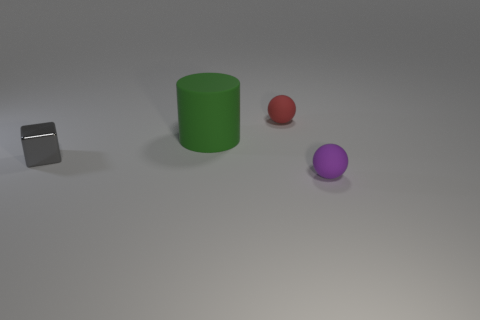What color is the large rubber object?
Make the answer very short. Green. There is a sphere that is on the right side of the red object; what number of red matte spheres are in front of it?
Give a very brief answer. 0. Is the size of the green rubber cylinder the same as the sphere that is in front of the large cylinder?
Provide a succinct answer. No. Do the gray cube and the purple matte sphere have the same size?
Provide a short and direct response. Yes. Are there any red objects that have the same size as the green cylinder?
Offer a very short reply. No. There is a small thing that is behind the big green rubber cylinder; what material is it?
Make the answer very short. Rubber. What color is the ball that is the same material as the red object?
Provide a short and direct response. Purple. How many matte objects are gray cubes or large spheres?
Your answer should be compact. 0. The gray object that is the same size as the red rubber ball is what shape?
Keep it short and to the point. Cube. How many objects are either small matte objects behind the small gray shiny object or balls that are to the right of the green rubber thing?
Offer a terse response. 2. 